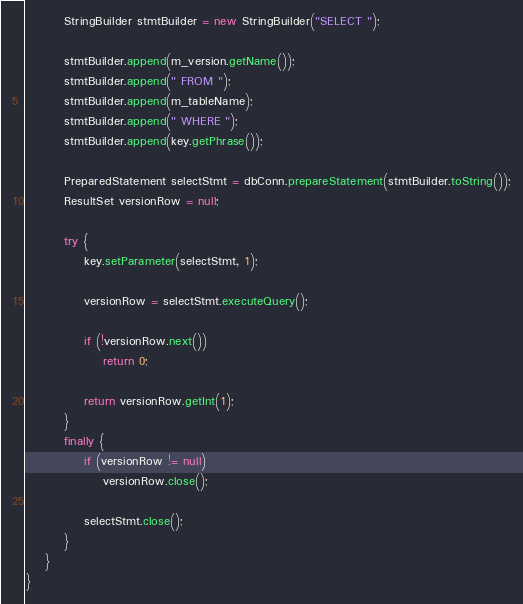Convert code to text. <code><loc_0><loc_0><loc_500><loc_500><_Java_>		StringBuilder stmtBuilder = new StringBuilder("SELECT ");

		stmtBuilder.append(m_version.getName());
		stmtBuilder.append(" FROM ");
		stmtBuilder.append(m_tableName);
		stmtBuilder.append(" WHERE ");
		stmtBuilder.append(key.getPhrase());

		PreparedStatement selectStmt = dbConn.prepareStatement(stmtBuilder.toString());
		ResultSet versionRow = null;

		try {
			key.setParameter(selectStmt, 1);

			versionRow = selectStmt.executeQuery();

			if (!versionRow.next())
				return 0;

			return versionRow.getInt(1);
		}
		finally {
			if (versionRow != null)
				versionRow.close();

			selectStmt.close();
		}
	}
}
</code> 